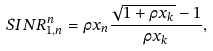Convert formula to latex. <formula><loc_0><loc_0><loc_500><loc_500>S I N R ^ { n } _ { 1 , n } & = \rho x _ { n } \frac { \sqrt { 1 + \rho x _ { k } } - 1 } { \rho x _ { k } } ,</formula> 